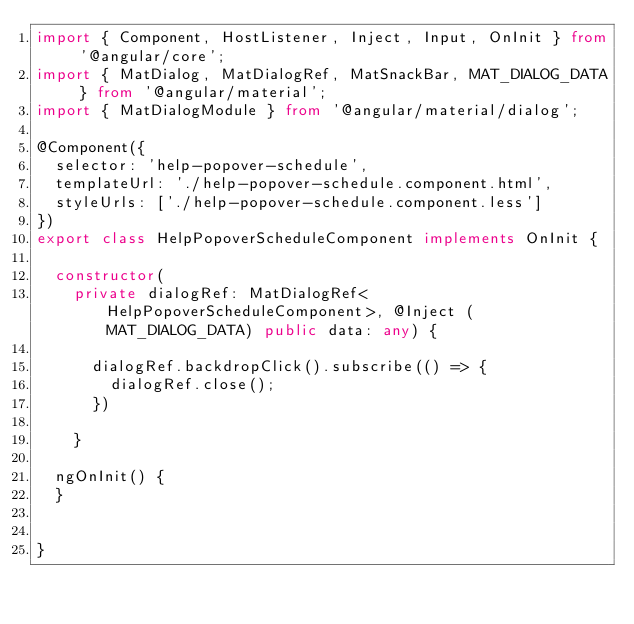<code> <loc_0><loc_0><loc_500><loc_500><_TypeScript_>import { Component, HostListener, Inject, Input, OnInit } from '@angular/core';
import { MatDialog, MatDialogRef, MatSnackBar, MAT_DIALOG_DATA } from '@angular/material';
import { MatDialogModule } from '@angular/material/dialog';

@Component({
  selector: 'help-popover-schedule',
  templateUrl: './help-popover-schedule.component.html',
  styleUrls: ['./help-popover-schedule.component.less']
})
export class HelpPopoverScheduleComponent implements OnInit {

  constructor(
    private dialogRef: MatDialogRef<HelpPopoverScheduleComponent>, @Inject (MAT_DIALOG_DATA) public data: any) {
      
      dialogRef.backdropClick().subscribe(() => {
        dialogRef.close();
      })

    }

  ngOnInit() {
  }
  

}
</code> 